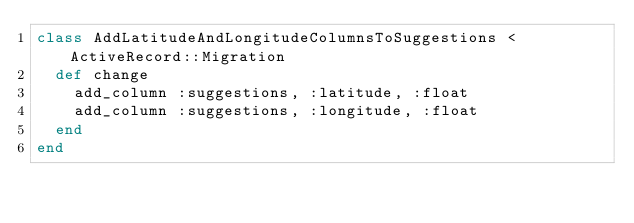Convert code to text. <code><loc_0><loc_0><loc_500><loc_500><_Ruby_>class AddLatitudeAndLongitudeColumnsToSuggestions < ActiveRecord::Migration
  def change
    add_column :suggestions, :latitude, :float
    add_column :suggestions, :longitude, :float
  end
end
</code> 